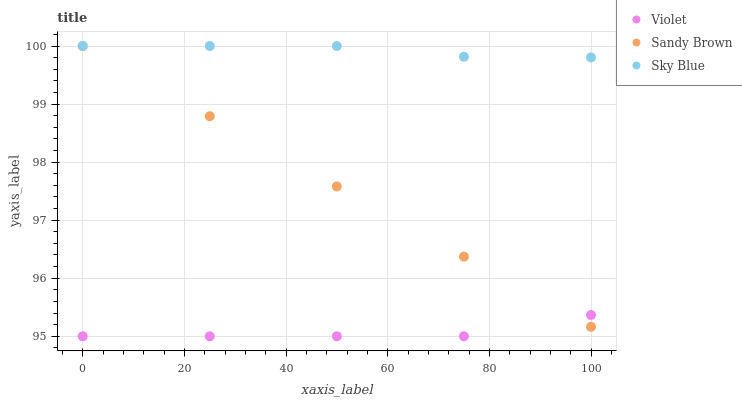Does Violet have the minimum area under the curve?
Answer yes or no. Yes. Does Sky Blue have the maximum area under the curve?
Answer yes or no. Yes. Does Sandy Brown have the minimum area under the curve?
Answer yes or no. No. Does Sandy Brown have the maximum area under the curve?
Answer yes or no. No. Is Sandy Brown the smoothest?
Answer yes or no. Yes. Is Violet the roughest?
Answer yes or no. Yes. Is Violet the smoothest?
Answer yes or no. No. Is Sandy Brown the roughest?
Answer yes or no. No. Does Violet have the lowest value?
Answer yes or no. Yes. Does Sandy Brown have the lowest value?
Answer yes or no. No. Does Sandy Brown have the highest value?
Answer yes or no. Yes. Does Violet have the highest value?
Answer yes or no. No. Is Violet less than Sky Blue?
Answer yes or no. Yes. Is Sky Blue greater than Violet?
Answer yes or no. Yes. Does Sky Blue intersect Sandy Brown?
Answer yes or no. Yes. Is Sky Blue less than Sandy Brown?
Answer yes or no. No. Is Sky Blue greater than Sandy Brown?
Answer yes or no. No. Does Violet intersect Sky Blue?
Answer yes or no. No. 